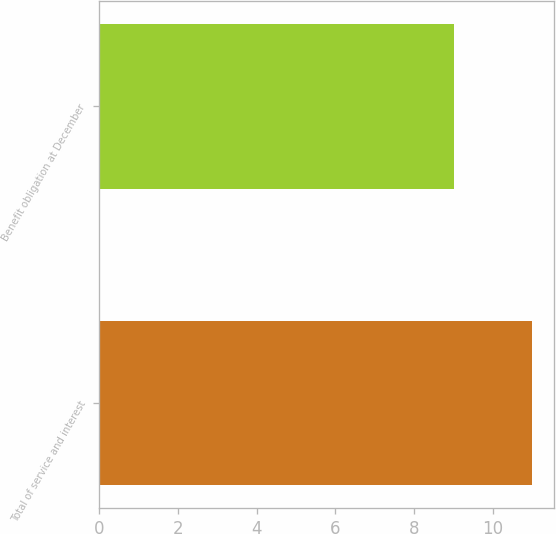Convert chart to OTSL. <chart><loc_0><loc_0><loc_500><loc_500><bar_chart><fcel>Total of service and interest<fcel>Benefit obligation at December<nl><fcel>11<fcel>9<nl></chart> 